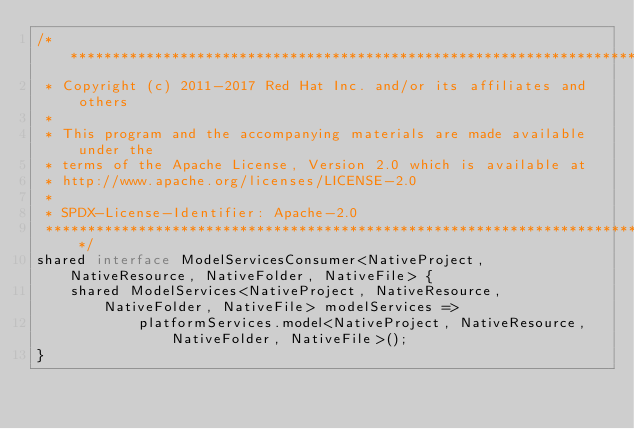Convert code to text. <code><loc_0><loc_0><loc_500><loc_500><_Ceylon_>/********************************************************************************
 * Copyright (c) 2011-2017 Red Hat Inc. and/or its affiliates and others
 *
 * This program and the accompanying materials are made available under the 
 * terms of the Apache License, Version 2.0 which is available at
 * http://www.apache.org/licenses/LICENSE-2.0
 *
 * SPDX-License-Identifier: Apache-2.0 
 ********************************************************************************/
shared interface ModelServicesConsumer<NativeProject, NativeResource, NativeFolder, NativeFile> {
    shared ModelServices<NativeProject, NativeResource, NativeFolder, NativeFile> modelServices =>
            platformServices.model<NativeProject, NativeResource, NativeFolder, NativeFile>();
}</code> 